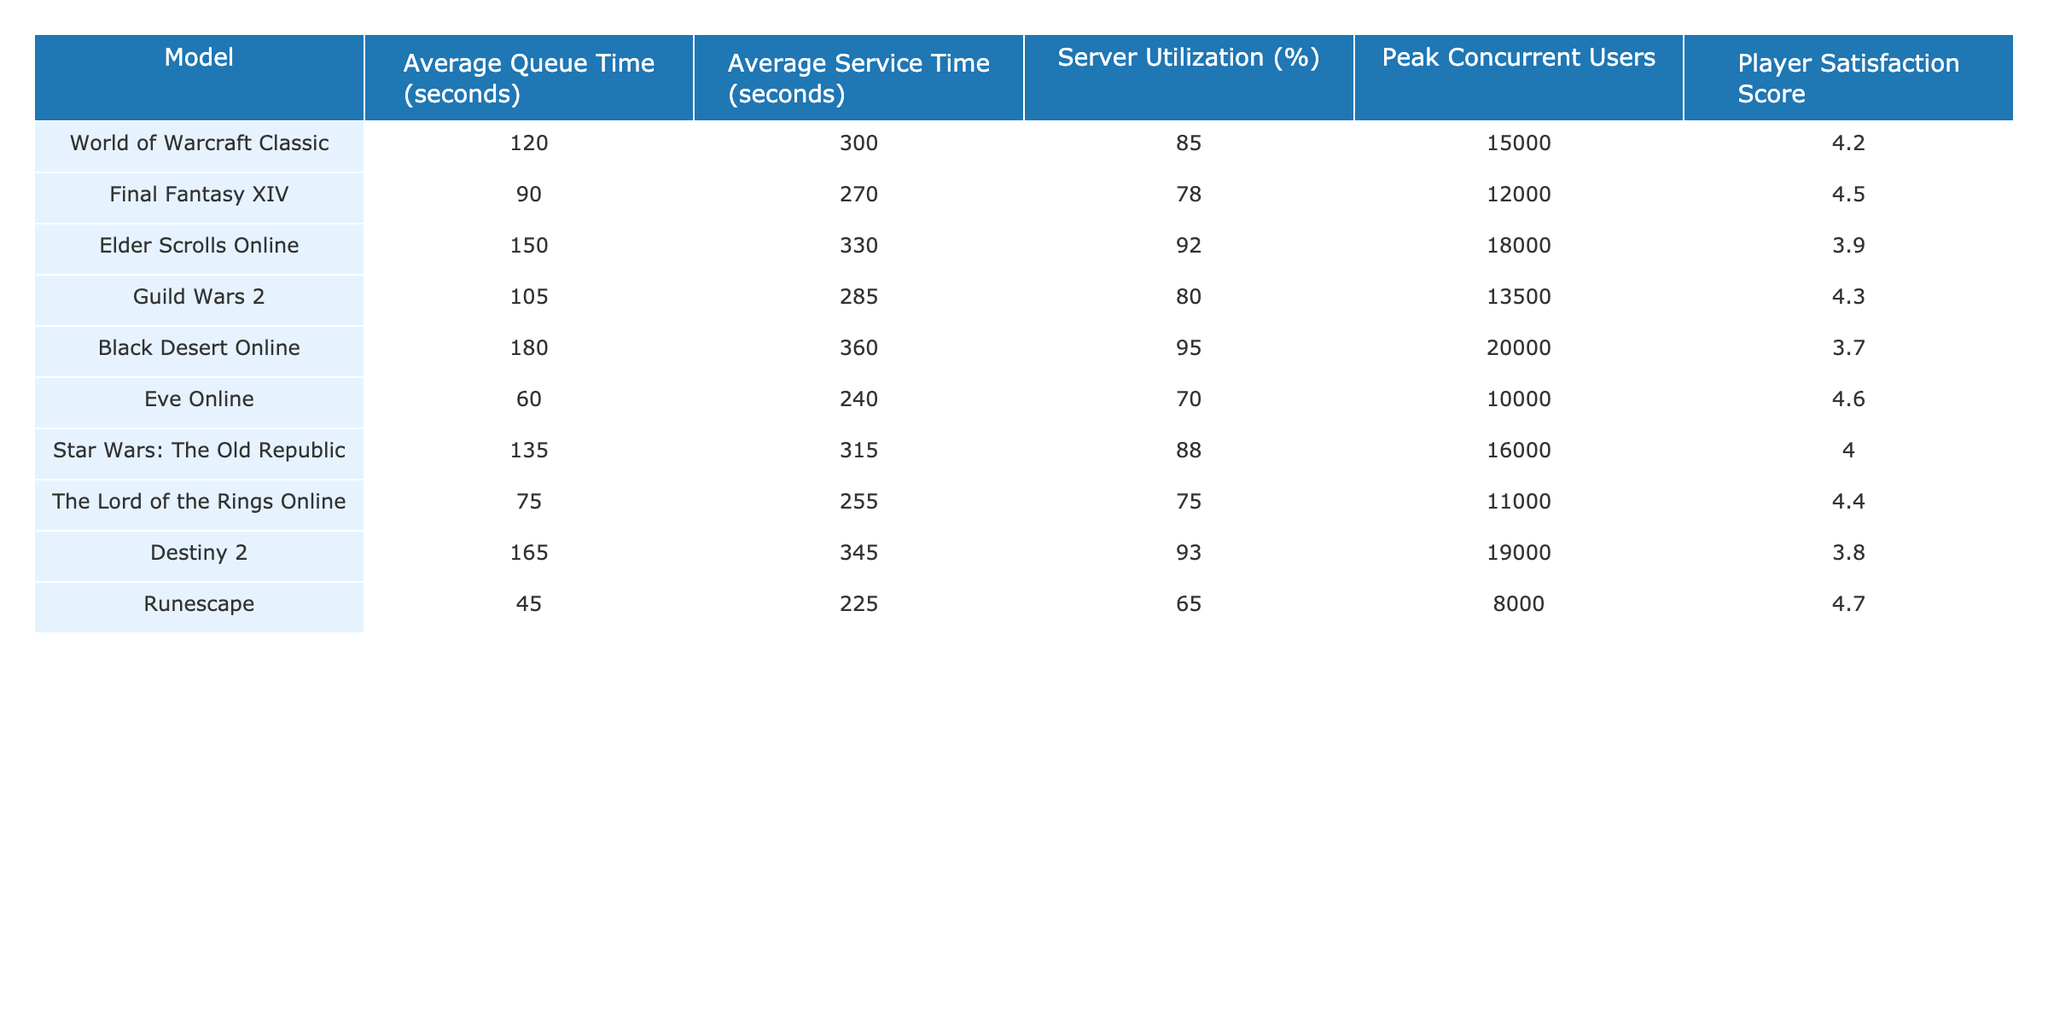What is the average queue time for Final Fantasy XIV? The average queue time for Final Fantasy XIV is directly listed in the table under the "Average Queue Time (seconds)" column, which shows a value of 90 seconds.
Answer: 90 seconds Which game has the highest player satisfaction score? By examining the "Player Satisfaction Score" column, we see that Eve Online has the highest score at 4.6, as it is greater than all other scores listed in the table.
Answer: 4.6 Is the average service time for Guild Wars 2 greater than that for Runescape? The average service time for Guild Wars 2 is 285 seconds, and for Runescape, it is 225 seconds. Since 285 is greater than 225, the answer is yes.
Answer: Yes What is the total server utilization percentage for all games? To find the total, we sum the server utilization percentages: 85 + 78 + 92 + 80 + 95 + 70 + 88 + 75 + 93 + 65 = 846. Therefore, the total server utilization for all games is 846%.
Answer: 846% Which game has the lowest peak concurrent users, and what is that number? Looking at the "Peak Concurrent Users" column, Runescape has the lowest, listed as 8000 players, which is less than any other game's number in that column.
Answer: 8000 What is the difference in average queue time between the game with the highest and lowest scores? The game with the highest queue time is Black Desert Online (180 seconds), and the lowest is Runescape (45 seconds). We perform the subtraction: 180 - 45 = 135 seconds.
Answer: 135 seconds Is the average service time for The Lord of the Rings Online less than 300 seconds? The table provides that The Lord of the Rings Online has an average service time of 255 seconds. Since 255 is less than 300, this statement is true.
Answer: Yes What is the average satisfaction score of all the games listed? To calculate the average, sum all satisfaction scores: 4.2 + 4.5 + 3.9 + 4.3 + 3.7 + 4.6 + 4.0 + 4.4 + 3.8 + 4.7 = 43.7. Then, divide by 10, the number of games: 43.7 / 10 = 4.37.
Answer: 4.37 